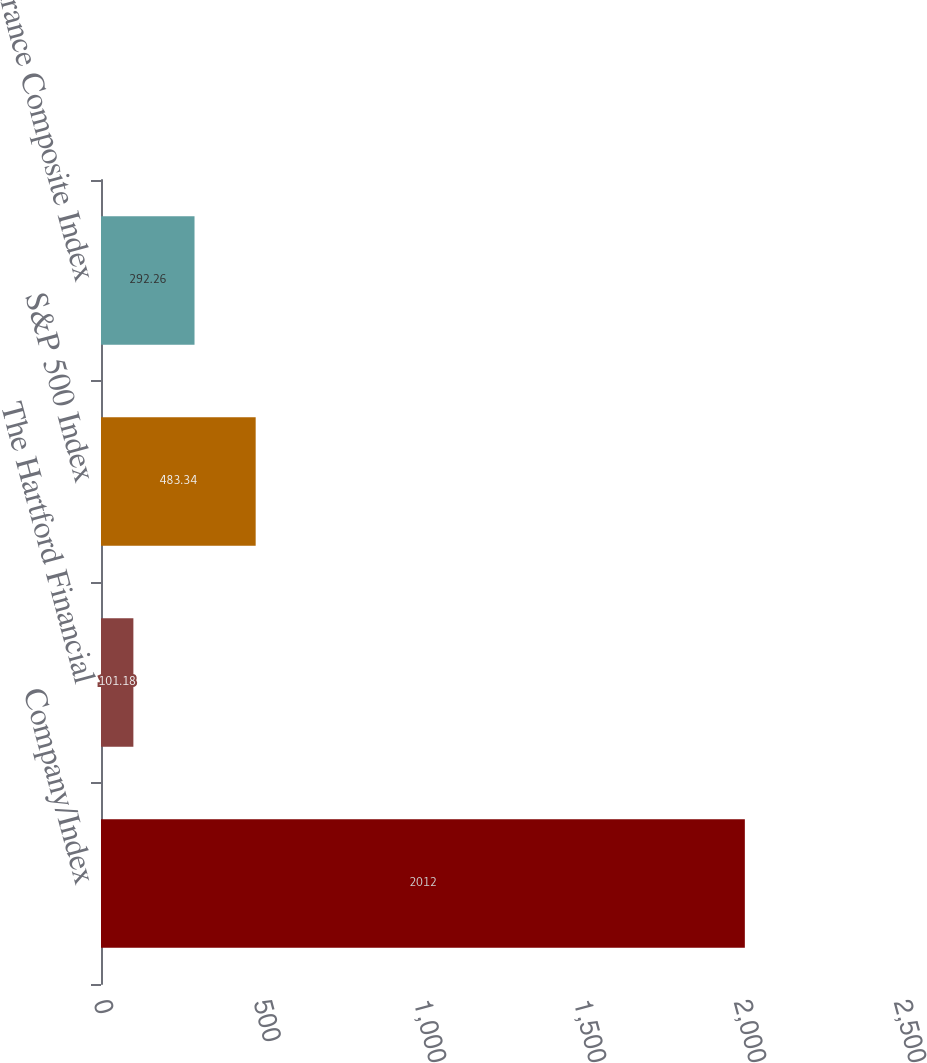Convert chart. <chart><loc_0><loc_0><loc_500><loc_500><bar_chart><fcel>Company/Index<fcel>The Hartford Financial<fcel>S&P 500 Index<fcel>S&P Insurance Composite Index<nl><fcel>2012<fcel>101.18<fcel>483.34<fcel>292.26<nl></chart> 